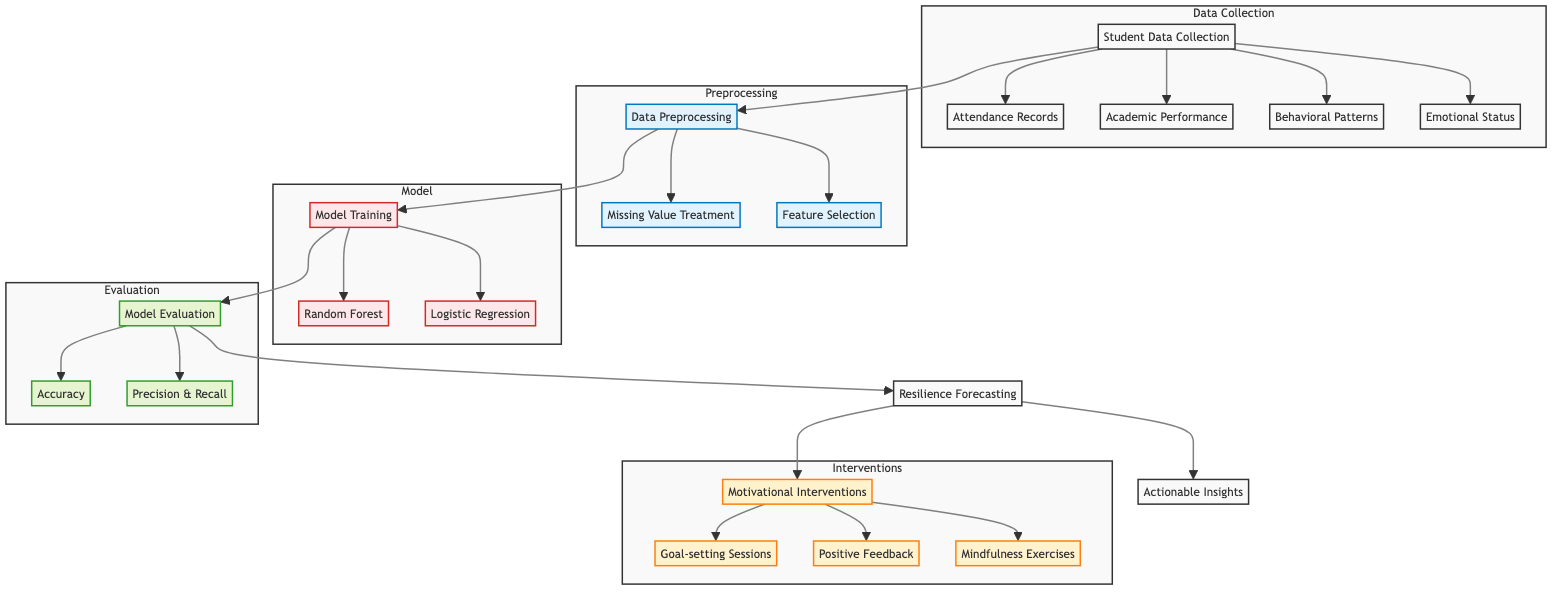What are the components of the data collection phase? The data collection phase consists of four components: Attendance Records, Academic Performance, Behavioral Patterns, and Emotional Status.
Answer: Attendance Records, Academic Performance, Behavioral Patterns, Emotional Status How many nodes are in the model section? In the model section, there are three nodes: Model Training, Random Forest, and Logistic Regression.
Answer: Three What follows after data preprocessing? After data preprocessing, Model Training follows, leading to the Random Forest and Logistic Regression nodes.
Answer: Model Training Which node leads to Resilience Forecasting? The Model Evaluation node leads to the Resilience Forecasting node, indicating it is a crucial step before forecasting.
Answer: Model Evaluation What type of interventions are indicated in the diagram? The interventions listed include Goal-setting Sessions, Positive Feedback, and Mindfulness Exercises, aimed at enhancing student resilience.
Answer: Goal-setting Sessions, Positive Feedback, Mindfulness Exercises How many types of measurements are used for model evaluation? There are two types of measurements used for model evaluation: Accuracy and Precision & Recall.
Answer: Two What is the output of the process after interventions? The output after the Motivational Interventions process is Actionable Insights, summarizing the implications of the interventions.
Answer: Actionable Insights Which phase involves treating missing values? Missing Value Treatment is a part of the Data Preprocessing phase, showing the importance of cleaning data before model training.
Answer: Data Preprocessing What is the structure of the flow from Student Data Collection? The flow from Student Data Collection branches into four distinct data sources: Attendance Records, Academic Performance, Behavioral Patterns, and Emotional Status, illustrating a comprehensive approach to student data.
Answer: Four distinct sources 